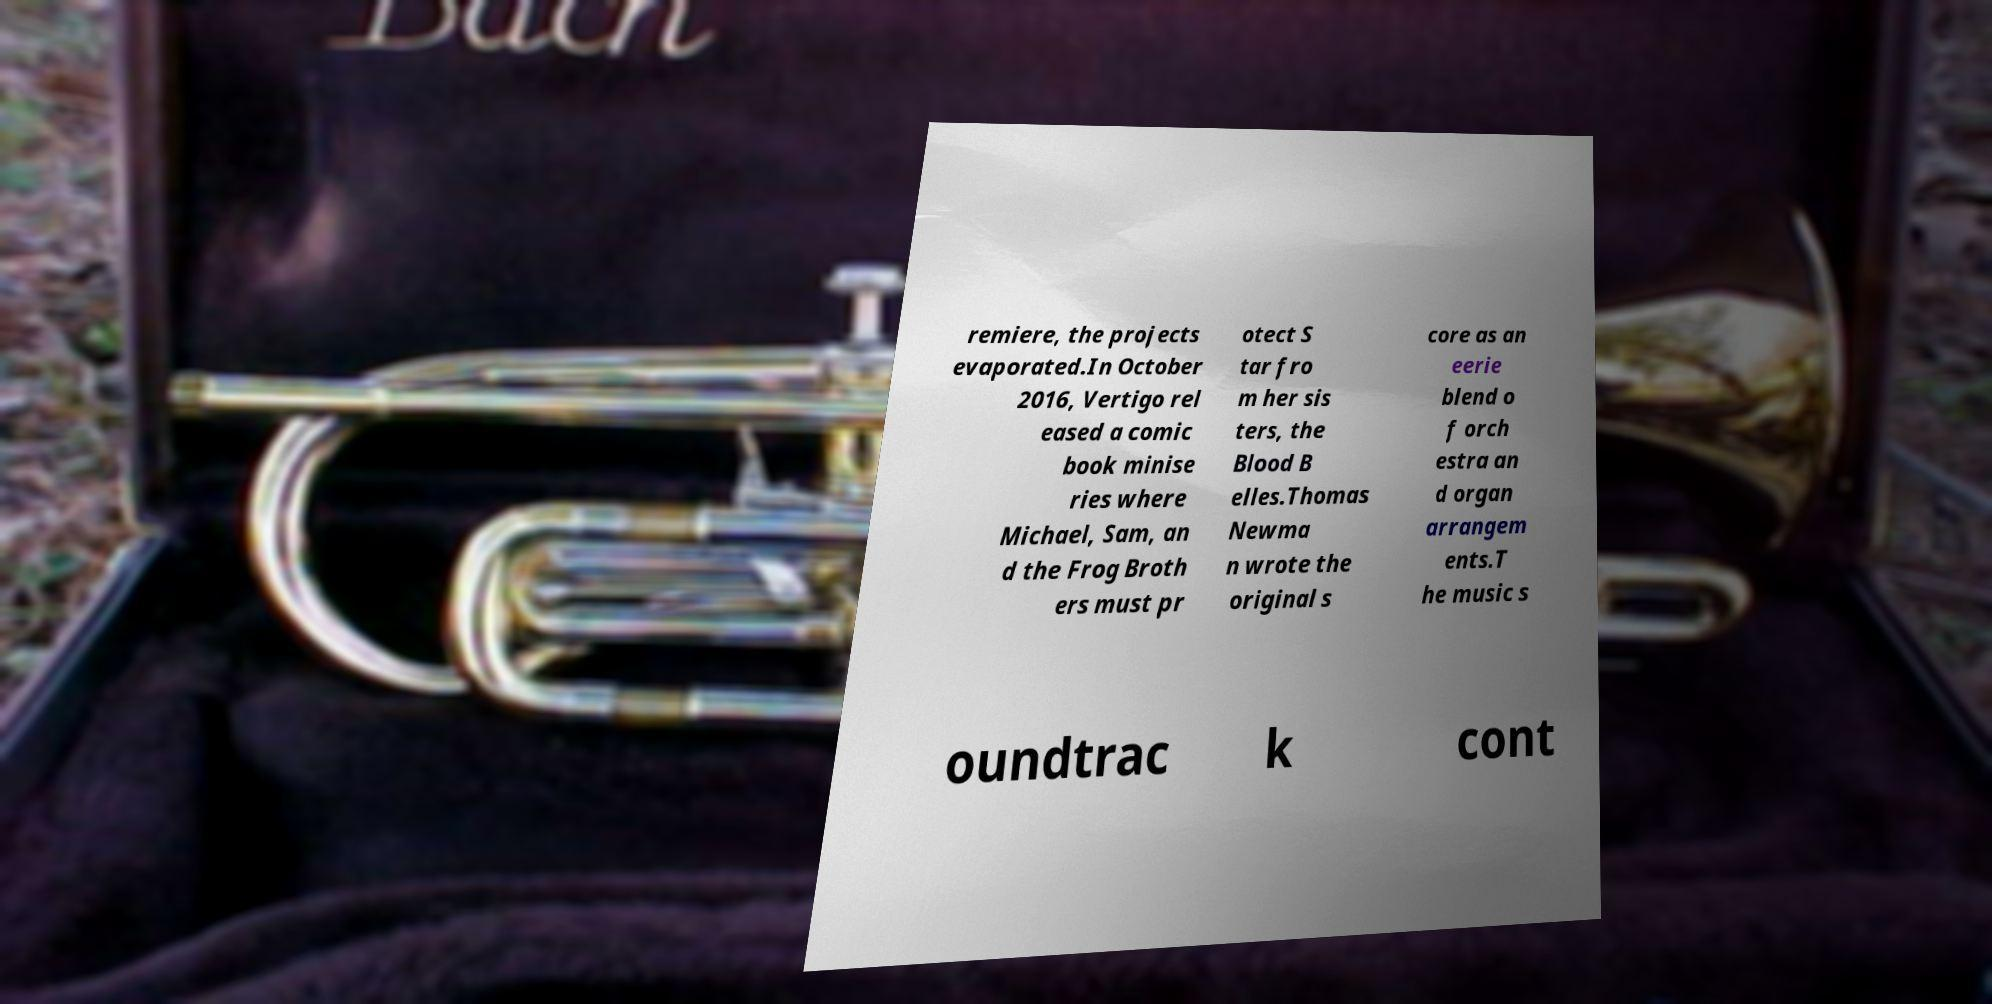Please identify and transcribe the text found in this image. remiere, the projects evaporated.In October 2016, Vertigo rel eased a comic book minise ries where Michael, Sam, an d the Frog Broth ers must pr otect S tar fro m her sis ters, the Blood B elles.Thomas Newma n wrote the original s core as an eerie blend o f orch estra an d organ arrangem ents.T he music s oundtrac k cont 